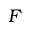Convert formula to latex. <formula><loc_0><loc_0><loc_500><loc_500>F</formula> 